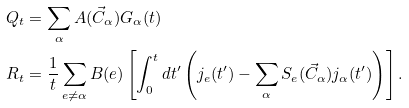Convert formula to latex. <formula><loc_0><loc_0><loc_500><loc_500>Q _ { t } & = \sum _ { \alpha } A ( \vec { C } _ { \alpha } ) G _ { \alpha } ( t ) \\ R _ { t } & = \frac { 1 } { t } \sum _ { e \neq { \alpha } } B ( e ) \left [ \int _ { 0 } ^ { t } d t ^ { \prime } \left ( j _ { e } ( t ^ { \prime } ) - \sum _ { \alpha } S _ { e } ( \vec { C } _ { \alpha } ) j _ { \alpha } ( t ^ { \prime } ) \right ) \right ] .</formula> 